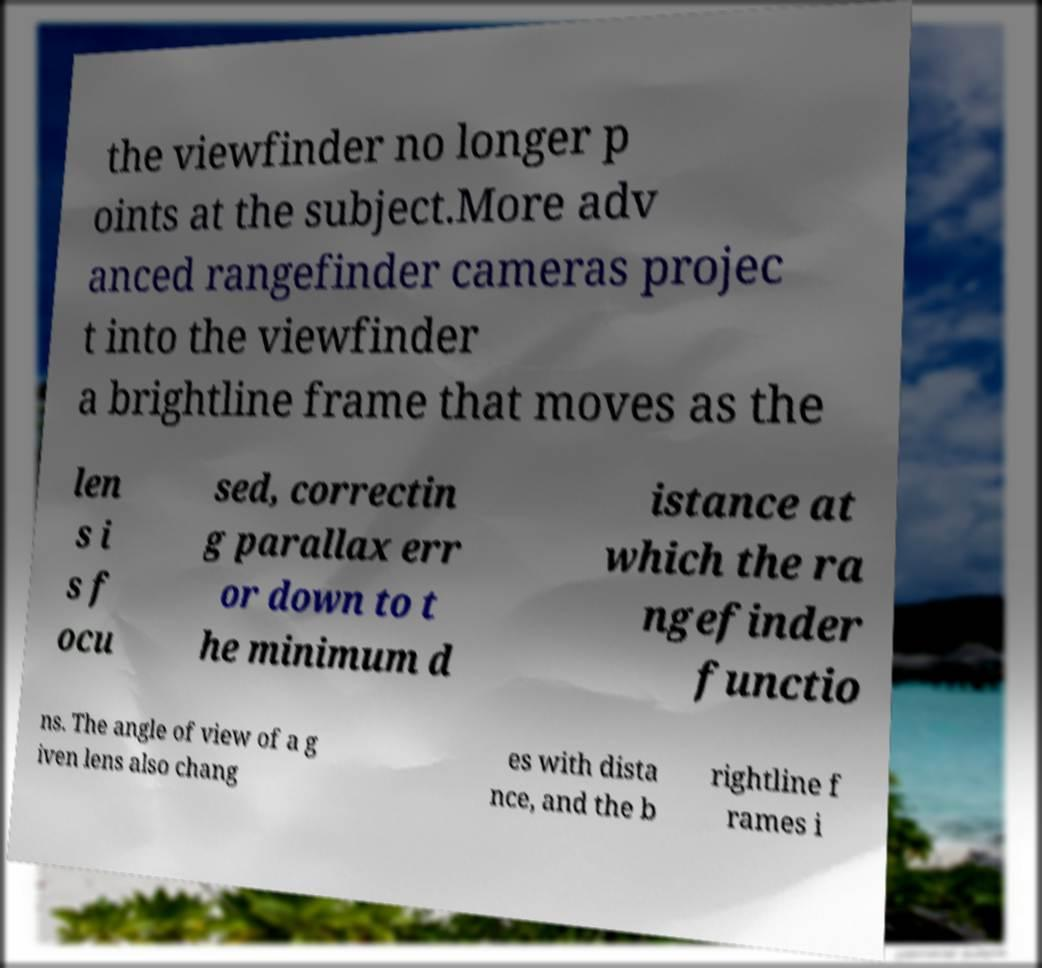Please read and relay the text visible in this image. What does it say? the viewfinder no longer p oints at the subject.More adv anced rangefinder cameras projec t into the viewfinder a brightline frame that moves as the len s i s f ocu sed, correctin g parallax err or down to t he minimum d istance at which the ra ngefinder functio ns. The angle of view of a g iven lens also chang es with dista nce, and the b rightline f rames i 